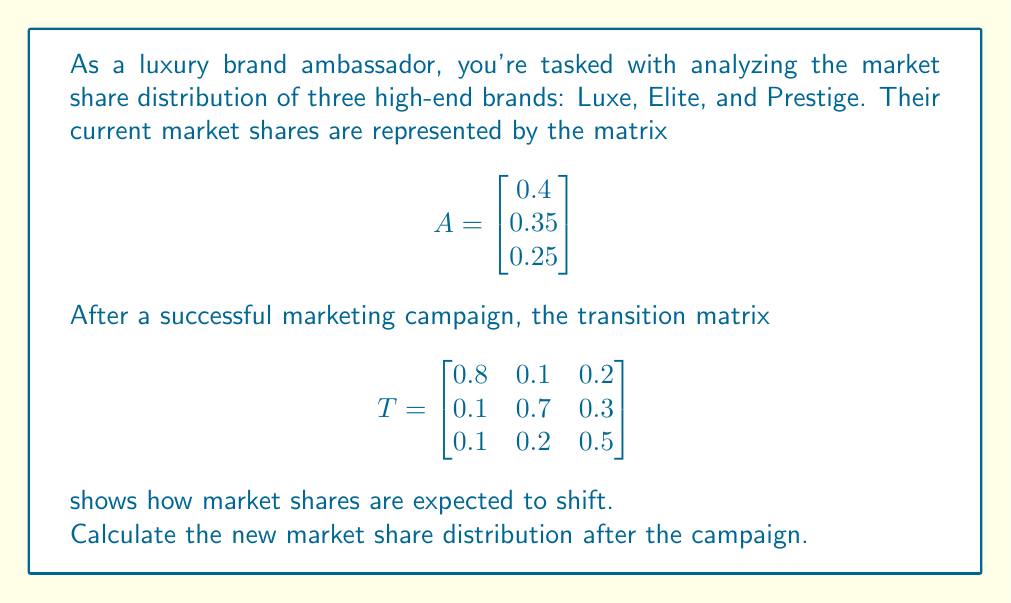Provide a solution to this math problem. To find the new market share distribution, we need to multiply the transition matrix T by the initial market share matrix A.

Step 1: Set up the matrix multiplication
$$T \cdot A = \begin{bmatrix} 0.8 & 0.1 & 0.2 \\ 0.1 & 0.7 & 0.3 \\ 0.1 & 0.2 & 0.5 \end{bmatrix} \cdot \begin{bmatrix} 0.4 \\ 0.35 \\ 0.25 \end{bmatrix}$$

Step 2: Perform the matrix multiplication
$$(0.8 \cdot 0.4) + (0.1 \cdot 0.35) + (0.2 \cdot 0.25) = 0.32 + 0.035 + 0.05 = 0.405$$
$$(0.1 \cdot 0.4) + (0.7 \cdot 0.35) + (0.3 \cdot 0.25) = 0.04 + 0.245 + 0.075 = 0.36$$
$$(0.1 \cdot 0.4) + (0.2 \cdot 0.35) + (0.5 \cdot 0.25) = 0.04 + 0.07 + 0.125 = 0.235$$

Step 3: Write the result as a new matrix
$$\begin{bmatrix} 0.405 \\ 0.36 \\ 0.235 \end{bmatrix}$$

This represents the new market share distribution for Luxe, Elite, and Prestige respectively.
Answer: $$\begin{bmatrix} 0.405 \\ 0.36 \\ 0.235 \end{bmatrix}$$ 